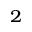<formula> <loc_0><loc_0><loc_500><loc_500>^ { 2 }</formula> 